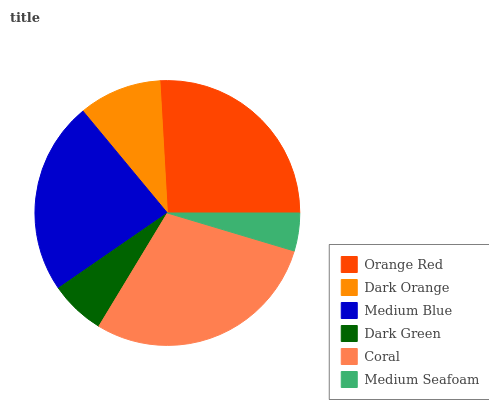Is Medium Seafoam the minimum?
Answer yes or no. Yes. Is Coral the maximum?
Answer yes or no. Yes. Is Dark Orange the minimum?
Answer yes or no. No. Is Dark Orange the maximum?
Answer yes or no. No. Is Orange Red greater than Dark Orange?
Answer yes or no. Yes. Is Dark Orange less than Orange Red?
Answer yes or no. Yes. Is Dark Orange greater than Orange Red?
Answer yes or no. No. Is Orange Red less than Dark Orange?
Answer yes or no. No. Is Medium Blue the high median?
Answer yes or no. Yes. Is Dark Orange the low median?
Answer yes or no. Yes. Is Orange Red the high median?
Answer yes or no. No. Is Medium Seafoam the low median?
Answer yes or no. No. 